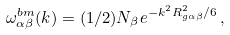<formula> <loc_0><loc_0><loc_500><loc_500>\omega ^ { b m } _ { \alpha \beta } ( k ) = ( 1 / 2 ) N _ { \beta } e ^ { - k ^ { 2 } R _ { g \alpha \beta } ^ { 2 } / 6 } \, ,</formula> 